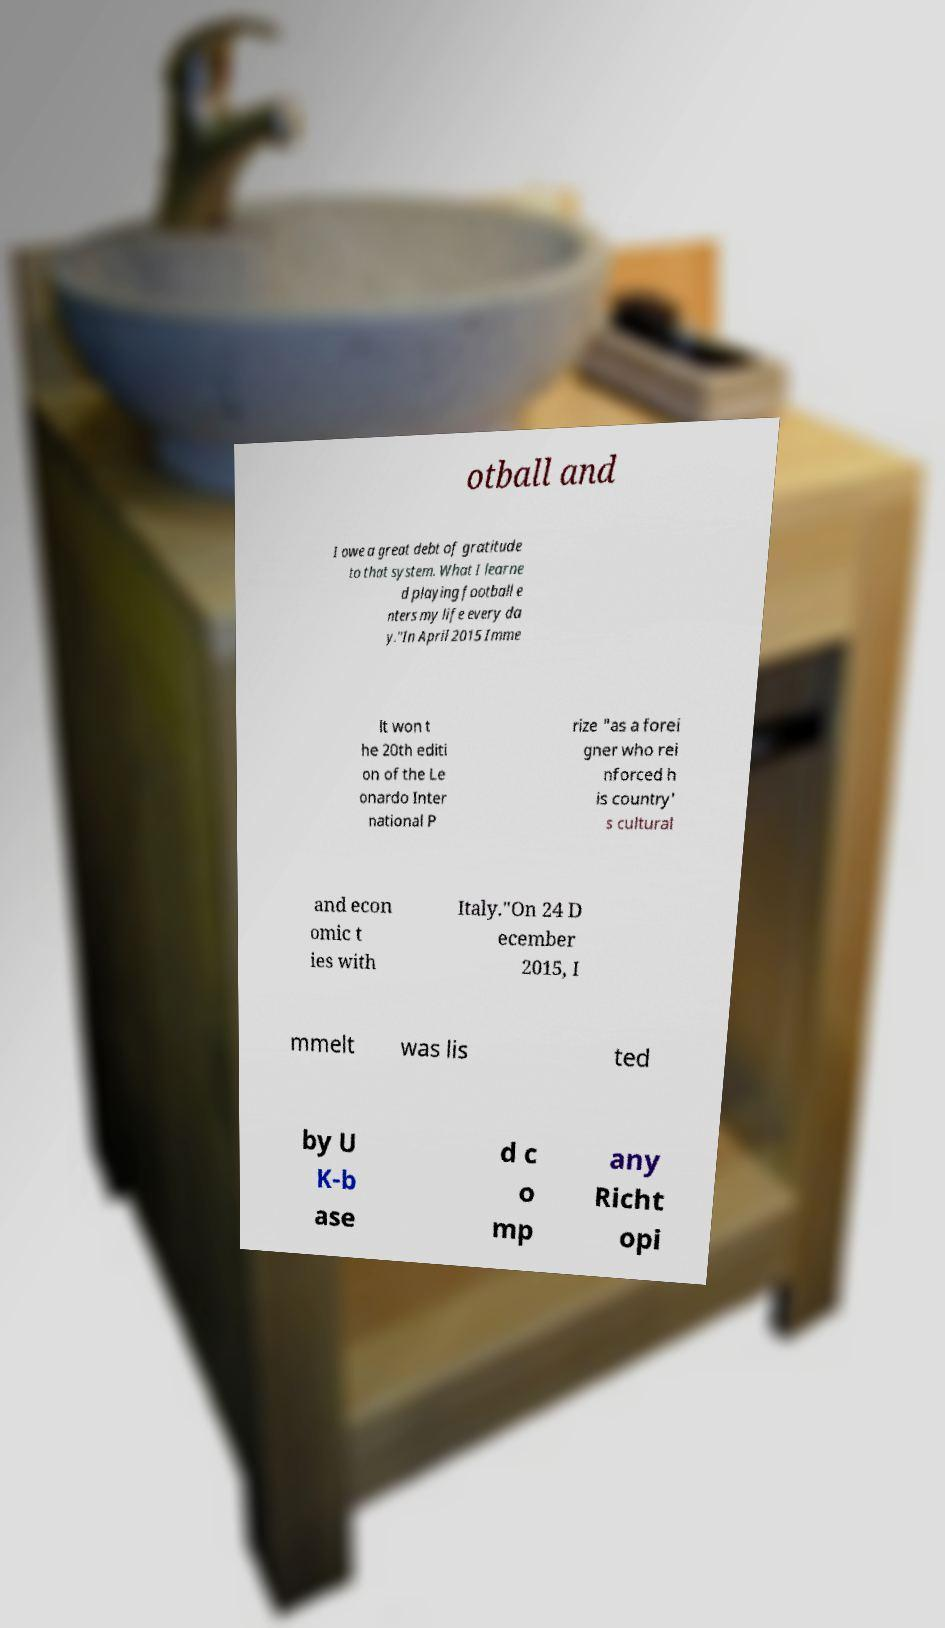What messages or text are displayed in this image? I need them in a readable, typed format. otball and I owe a great debt of gratitude to that system. What I learne d playing football e nters my life every da y."In April 2015 Imme lt won t he 20th editi on of the Le onardo Inter national P rize "as a forei gner who rei nforced h is country' s cultural and econ omic t ies with Italy."On 24 D ecember 2015, I mmelt was lis ted by U K-b ase d c o mp any Richt opi 